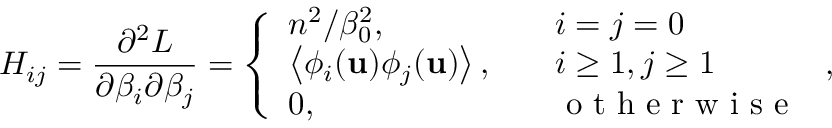Convert formula to latex. <formula><loc_0><loc_0><loc_500><loc_500>H _ { i j } = \frac { \partial ^ { 2 } L } { \partial \beta _ { i } \partial \beta _ { j } } = \left \{ \begin{array} { l l } { n ^ { 2 } / \beta _ { 0 } ^ { 2 } , \quad } & { i = j = 0 } \\ { \left < \phi _ { i } ( u ) \phi _ { j } ( u ) \right > , \quad } & { i \geq 1 , j \geq 1 } \\ { 0 , \quad } & { o t h e r w i s e } \end{array} ,</formula> 